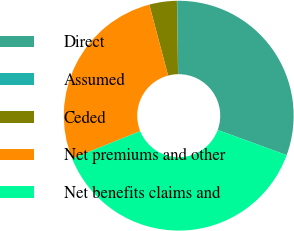Convert chart to OTSL. <chart><loc_0><loc_0><loc_500><loc_500><pie_chart><fcel>Direct<fcel>Assumed<fcel>Ceded<fcel>Net premiums and other<fcel>Net benefits claims and<nl><fcel>30.79%<fcel>0.04%<fcel>3.87%<fcel>26.96%<fcel>38.34%<nl></chart> 